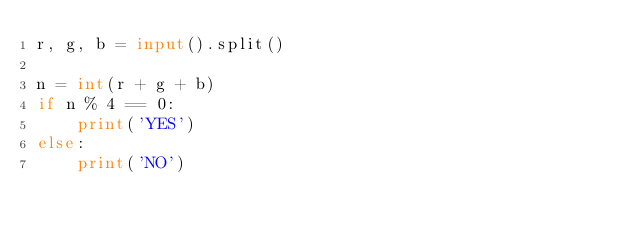<code> <loc_0><loc_0><loc_500><loc_500><_Python_>r, g, b = input().split()

n = int(r + g + b)
if n % 4 == 0:
    print('YES')
else:
    print('NO')</code> 